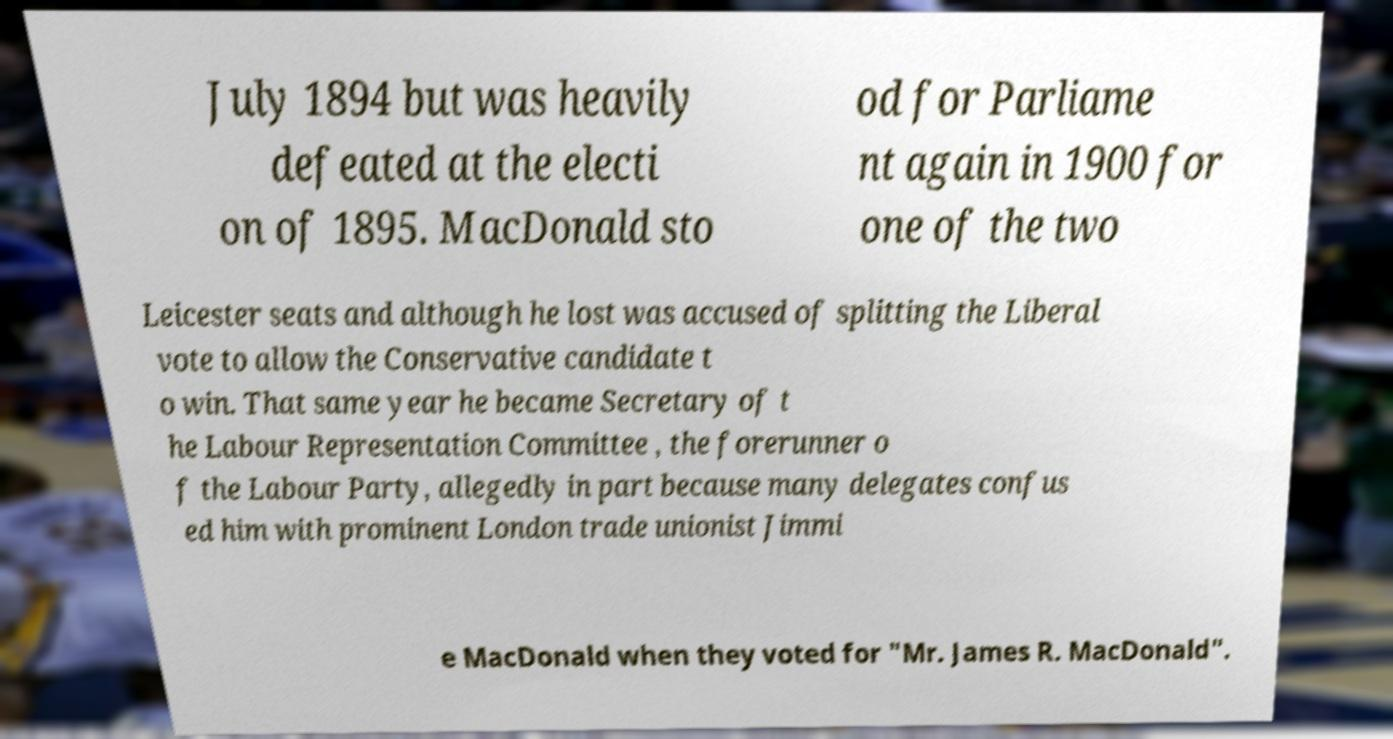Can you read and provide the text displayed in the image?This photo seems to have some interesting text. Can you extract and type it out for me? July 1894 but was heavily defeated at the electi on of 1895. MacDonald sto od for Parliame nt again in 1900 for one of the two Leicester seats and although he lost was accused of splitting the Liberal vote to allow the Conservative candidate t o win. That same year he became Secretary of t he Labour Representation Committee , the forerunner o f the Labour Party, allegedly in part because many delegates confus ed him with prominent London trade unionist Jimmi e MacDonald when they voted for "Mr. James R. MacDonald". 